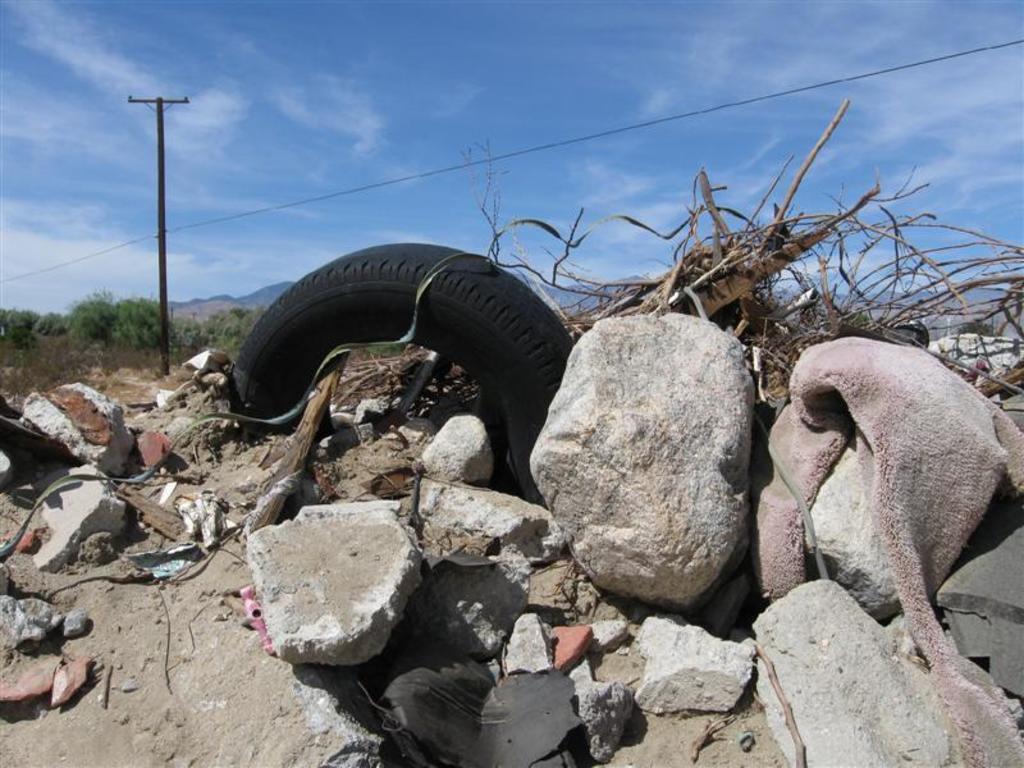In one or two sentences, can you explain what this image depicts? In this picture I can see there is a tire, rocks, twigs and there are few trees in the backdrop, there is an electric pole and the sky is clear. 